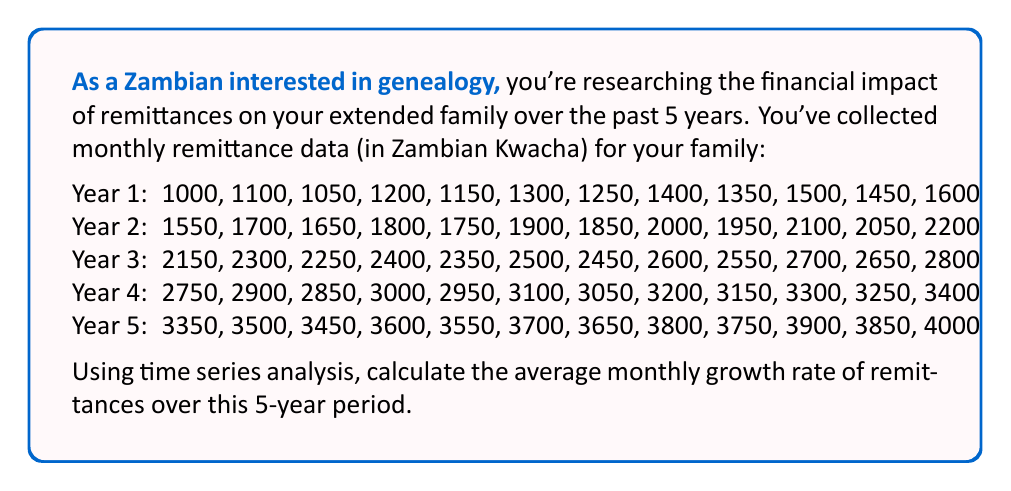Give your solution to this math problem. To calculate the average monthly growth rate, we'll use the compound annual growth rate (CAGR) formula and adjust it for monthly periods:

1) First, identify the initial value (IV) and final value (FV):
   IV = 1000 (first month of Year 1)
   FV = 4000 (last month of Year 5)

2) Determine the number of periods (n):
   5 years * 12 months = 60 months

3) Use the monthly CAGR formula:
   $$\text{Monthly Growth Rate} = \left(\frac{FV}{IV}\right)^{\frac{1}{n}} - 1$$

4) Plug in the values:
   $$\text{Monthly Growth Rate} = \left(\frac{4000}{1000}\right)^{\frac{1}{60}} - 1$$

5) Simplify:
   $$\text{Monthly Growth Rate} = (4)^{\frac{1}{60}} - 1$$

6) Calculate:
   $$\text{Monthly Growth Rate} = 1.0233 - 1 = 0.0233$$

7) Convert to percentage:
   0.0233 * 100 = 2.33%

Therefore, the average monthly growth rate of remittances over the 5-year period is approximately 2.33%.
Answer: 2.33% 